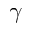Convert formula to latex. <formula><loc_0><loc_0><loc_500><loc_500>\gamma</formula> 